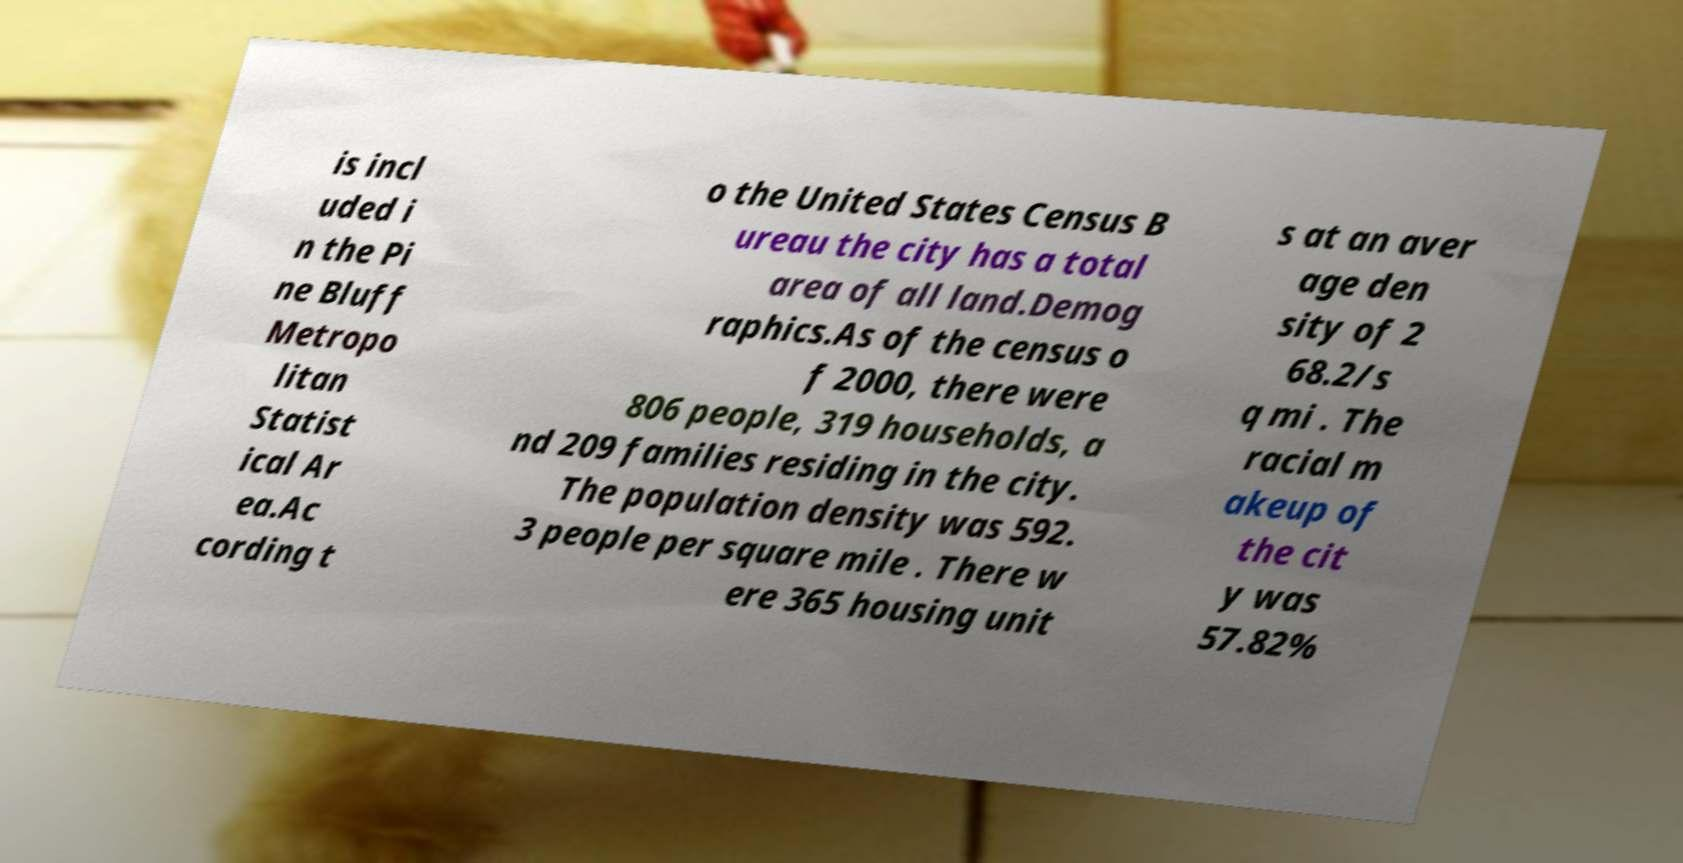What messages or text are displayed in this image? I need them in a readable, typed format. is incl uded i n the Pi ne Bluff Metropo litan Statist ical Ar ea.Ac cording t o the United States Census B ureau the city has a total area of all land.Demog raphics.As of the census o f 2000, there were 806 people, 319 households, a nd 209 families residing in the city. The population density was 592. 3 people per square mile . There w ere 365 housing unit s at an aver age den sity of 2 68.2/s q mi . The racial m akeup of the cit y was 57.82% 